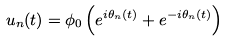Convert formula to latex. <formula><loc_0><loc_0><loc_500><loc_500>u _ { n } ( t ) = \phi _ { 0 } \left ( e ^ { i \theta _ { n } ( t ) } + e ^ { - i \theta _ { n } ( t ) } \right )</formula> 